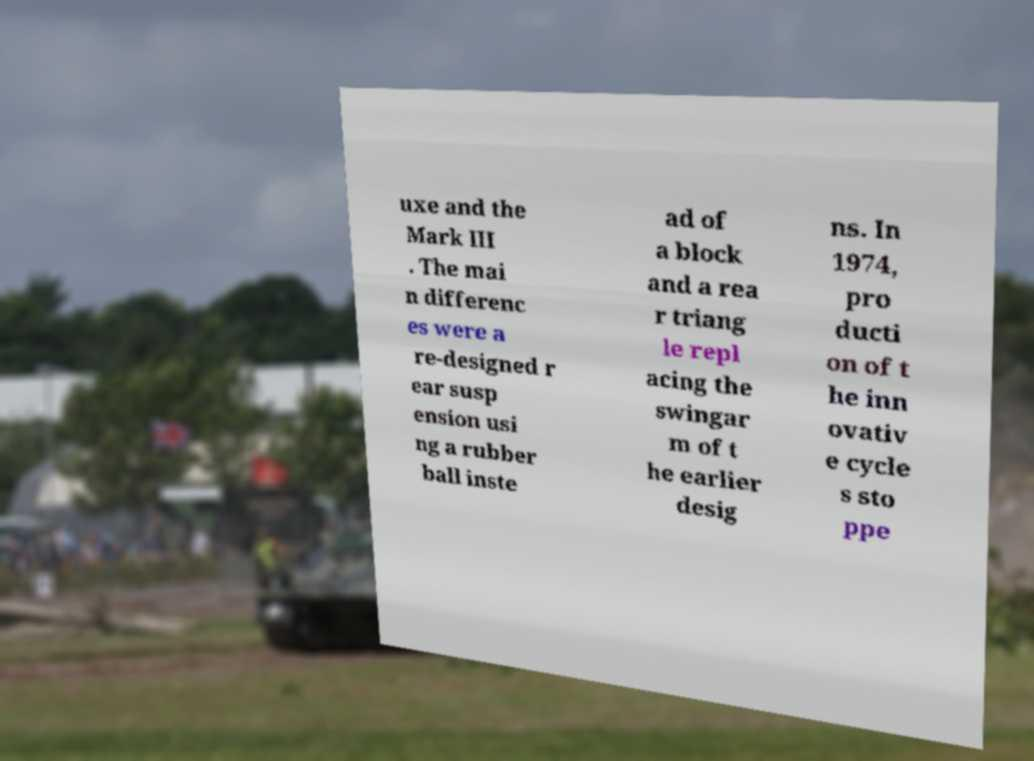Can you accurately transcribe the text from the provided image for me? uxe and the Mark III . The mai n differenc es were a re-designed r ear susp ension usi ng a rubber ball inste ad of a block and a rea r triang le repl acing the swingar m of t he earlier desig ns. In 1974, pro ducti on of t he inn ovativ e cycle s sto ppe 